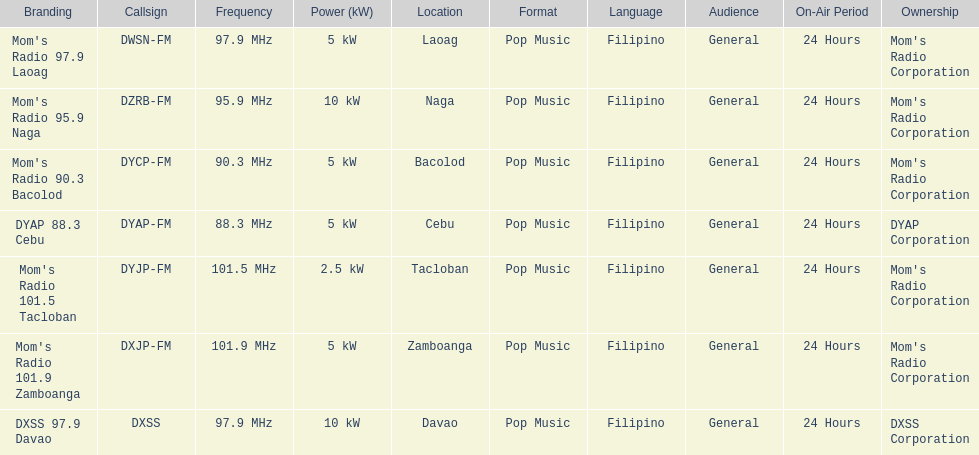What is the radio with the least about of mhz? DYAP 88.3 Cebu. 